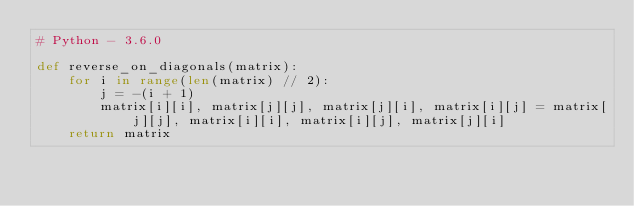Convert code to text. <code><loc_0><loc_0><loc_500><loc_500><_Python_># Python - 3.6.0

def reverse_on_diagonals(matrix):
    for i in range(len(matrix) // 2):
        j = -(i + 1)
        matrix[i][i], matrix[j][j], matrix[j][i], matrix[i][j] = matrix[j][j], matrix[i][i], matrix[i][j], matrix[j][i]
    return matrix
</code> 